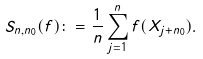Convert formula to latex. <formula><loc_0><loc_0><loc_500><loc_500>S _ { n , n _ { 0 } } ( f ) \colon = \frac { 1 } { n } \sum _ { j = 1 } ^ { n } f ( X _ { j + n _ { 0 } } ) .</formula> 